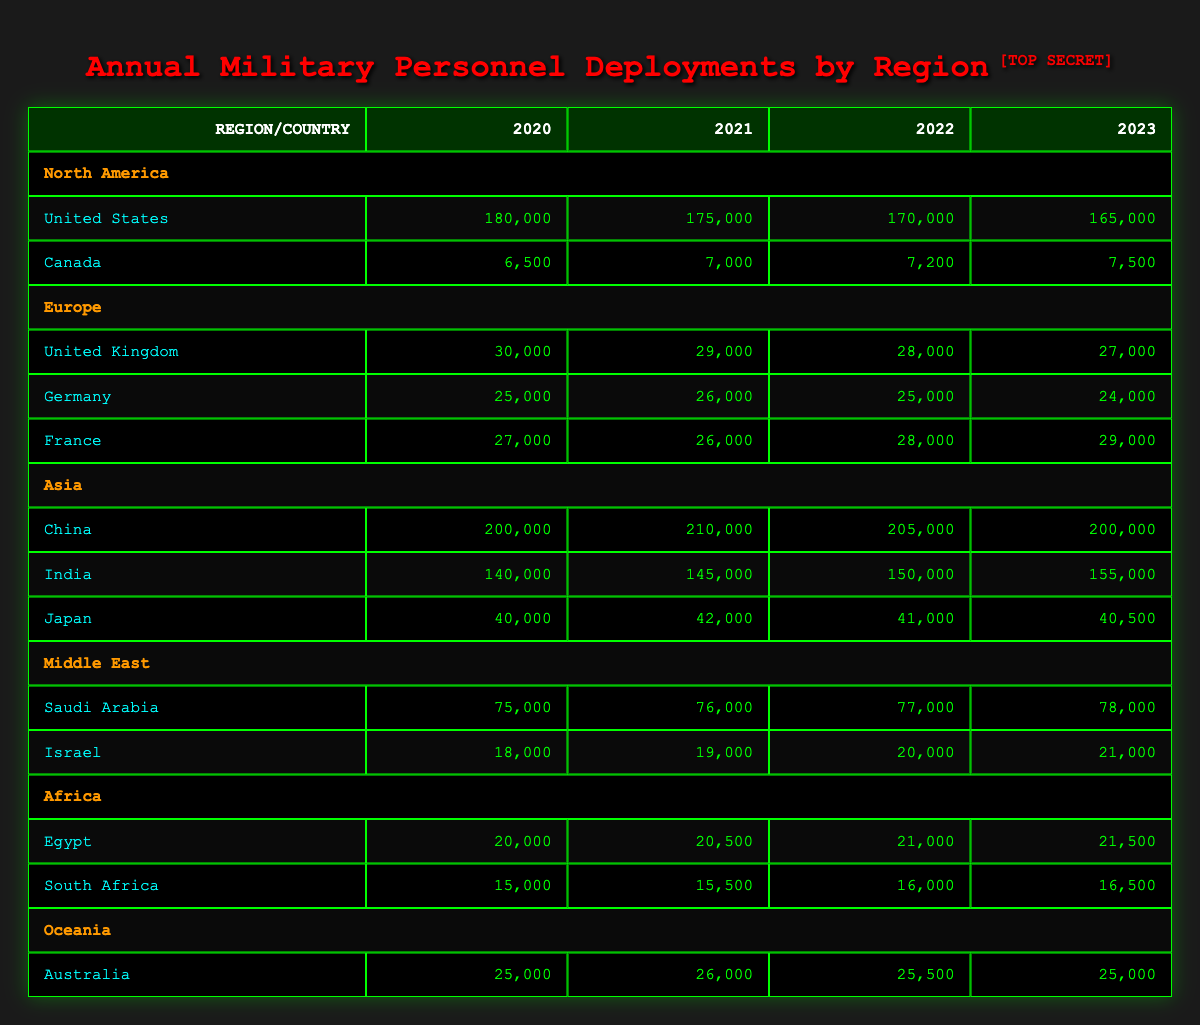What was the military personnel deployment of China in 2022? According to the table, China had a deployment of 205,000 military personnel in 2022, which is stated directly under the Asia region for that year.
Answer: 205,000 Which country in North America had the highest military personnel deployment in 2020? The table shows that the United States had the highest deployment in North America for 2020, with 180,000 personnel, compared to Canada's 6,500.
Answer: United States What is the total military personnel deployment for Germany from 2020 to 2023? To find the total, we add Germany's deployments for the four years: 25,000 (2020) + 26,000 (2021) + 25,000 (2022) + 24,000 (2023) = 100,000.
Answer: 100,000 Did Israel's military personnel deployment increase every year from 2020 to 2023? By examining the table, Israel's deployment was 18,000 in 2020, increasing to 19,000 in 2021, 20,000 in 2022, and 21,000 in 2023, indicating a consistent increase.
Answer: Yes What is the average annual military personnel deployment for Canada from 2020 to 2023? To calculate the average, sum Canada's deployments: 6,500 (2020) + 7,000 (2021) + 7,200 (2022) + 7,500 (2023) = 28,200. Then, divide by 4 (the number of years): 28,200 / 4 = 7,050.
Answer: 7,050 What was the change in military personnel deployment for the United Kingdom from 2020 to 2023? The deployment decreased from 30,000 in 2020 to 27,000 in 2023, making the change: 30,000 - 27,000 = 3,000, which is a decrease over these years.
Answer: Decrease of 3,000 Which region had the highest deployment of military personnel in 2021? In 2021, the table shows that China in Asia had the highest deployment with 210,000 military personnel, above all other countries listed.
Answer: Asia What was the total military personnel deployment from South Africa and Egypt in 2023? In 2023, South Africa deployed 16,500 and Egypt deployed 21,500. Therefore, the total is 16,500 + 21,500 = 38,000.
Answer: 38,000 Which country had a constant deployment of military personnel over the periods shown? The data shows Japan had the same deployment in 2020 (40,000) and again in 2023 (40,500) with only slight variations in 2021 and 2022. This indicates Japan had two years with similar values but no other countries had no changes.
Answer: None 